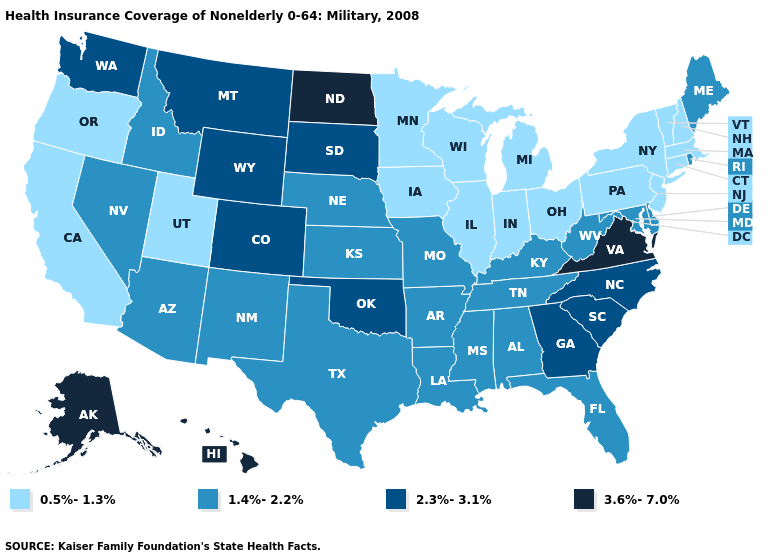What is the lowest value in states that border Colorado?
Give a very brief answer. 0.5%-1.3%. What is the value of Hawaii?
Give a very brief answer. 3.6%-7.0%. Does Louisiana have a higher value than Montana?
Give a very brief answer. No. Is the legend a continuous bar?
Short answer required. No. Which states have the lowest value in the USA?
Write a very short answer. California, Connecticut, Illinois, Indiana, Iowa, Massachusetts, Michigan, Minnesota, New Hampshire, New Jersey, New York, Ohio, Oregon, Pennsylvania, Utah, Vermont, Wisconsin. Does South Dakota have the highest value in the MidWest?
Concise answer only. No. What is the lowest value in the USA?
Write a very short answer. 0.5%-1.3%. Which states have the lowest value in the USA?
Short answer required. California, Connecticut, Illinois, Indiana, Iowa, Massachusetts, Michigan, Minnesota, New Hampshire, New Jersey, New York, Ohio, Oregon, Pennsylvania, Utah, Vermont, Wisconsin. What is the value of New Hampshire?
Write a very short answer. 0.5%-1.3%. Does Iowa have a lower value than California?
Be succinct. No. How many symbols are there in the legend?
Short answer required. 4. Which states have the lowest value in the West?
Quick response, please. California, Oregon, Utah. What is the lowest value in states that border Wisconsin?
Give a very brief answer. 0.5%-1.3%. What is the value of Rhode Island?
Be succinct. 1.4%-2.2%. Name the states that have a value in the range 3.6%-7.0%?
Write a very short answer. Alaska, Hawaii, North Dakota, Virginia. 